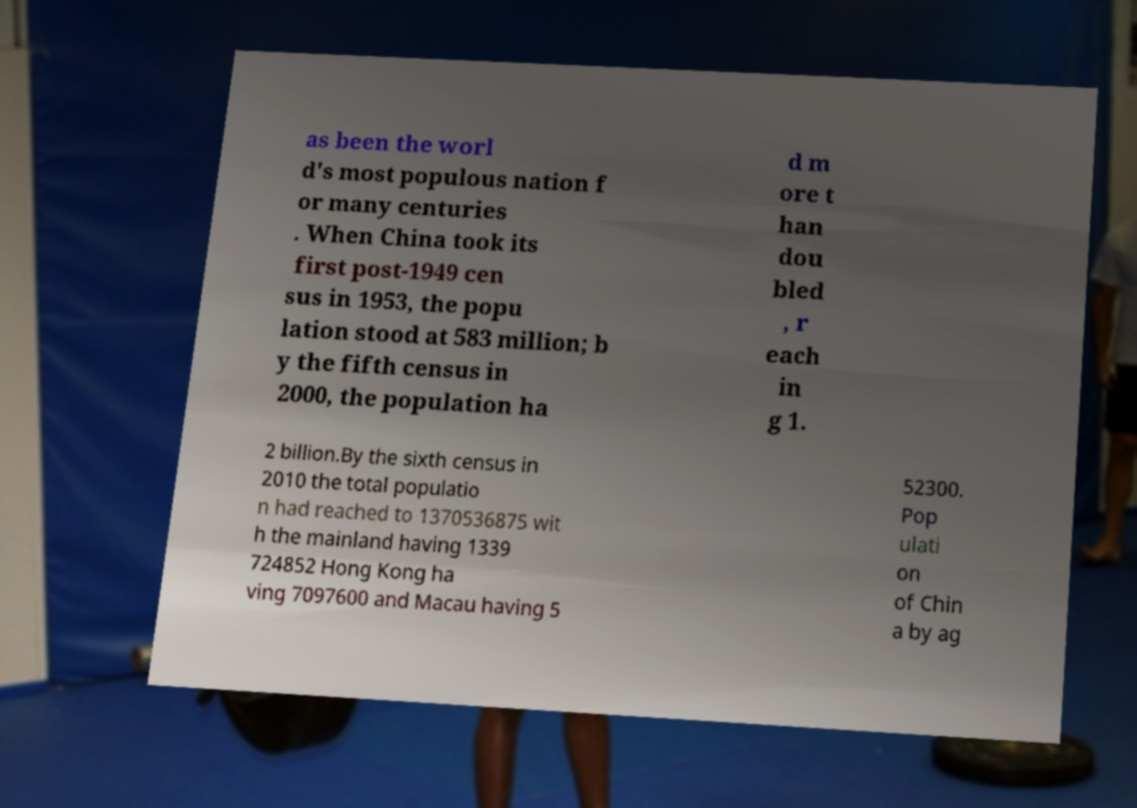Could you assist in decoding the text presented in this image and type it out clearly? as been the worl d's most populous nation f or many centuries . When China took its first post-1949 cen sus in 1953, the popu lation stood at 583 million; b y the fifth census in 2000, the population ha d m ore t han dou bled , r each in g 1. 2 billion.By the sixth census in 2010 the total populatio n had reached to 1370536875 wit h the mainland having 1339 724852 Hong Kong ha ving 7097600 and Macau having 5 52300. Pop ulati on of Chin a by ag 